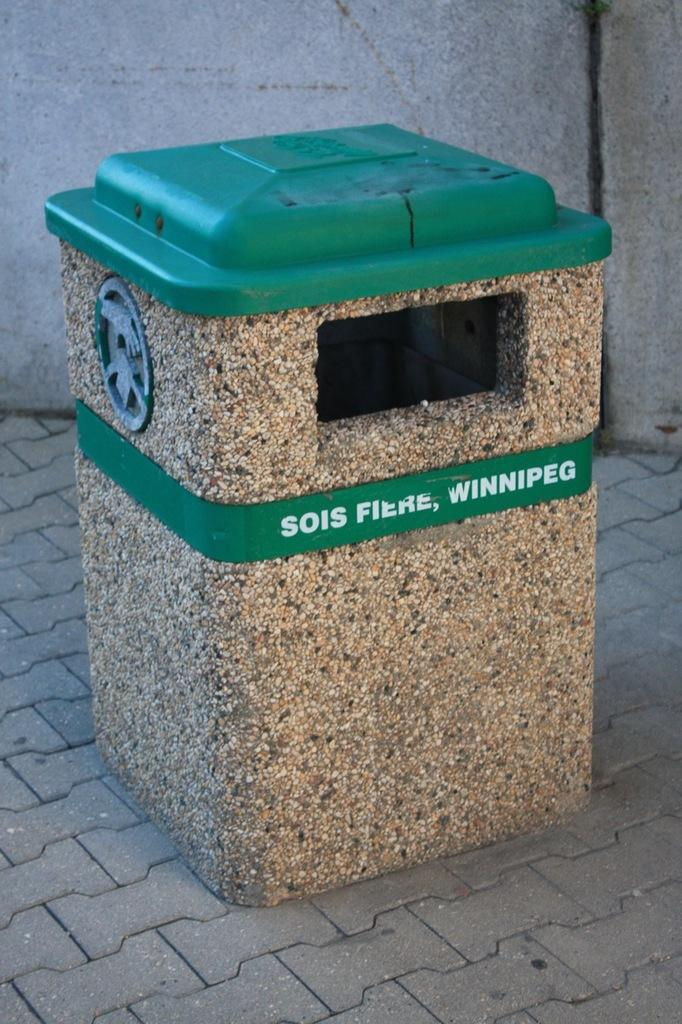Provide a one-sentence caption for the provided image. A TRASH CAN WITH A GREEN LID AND LABEL THAT STATES "SOIS FIERE, WINNIPEG". 